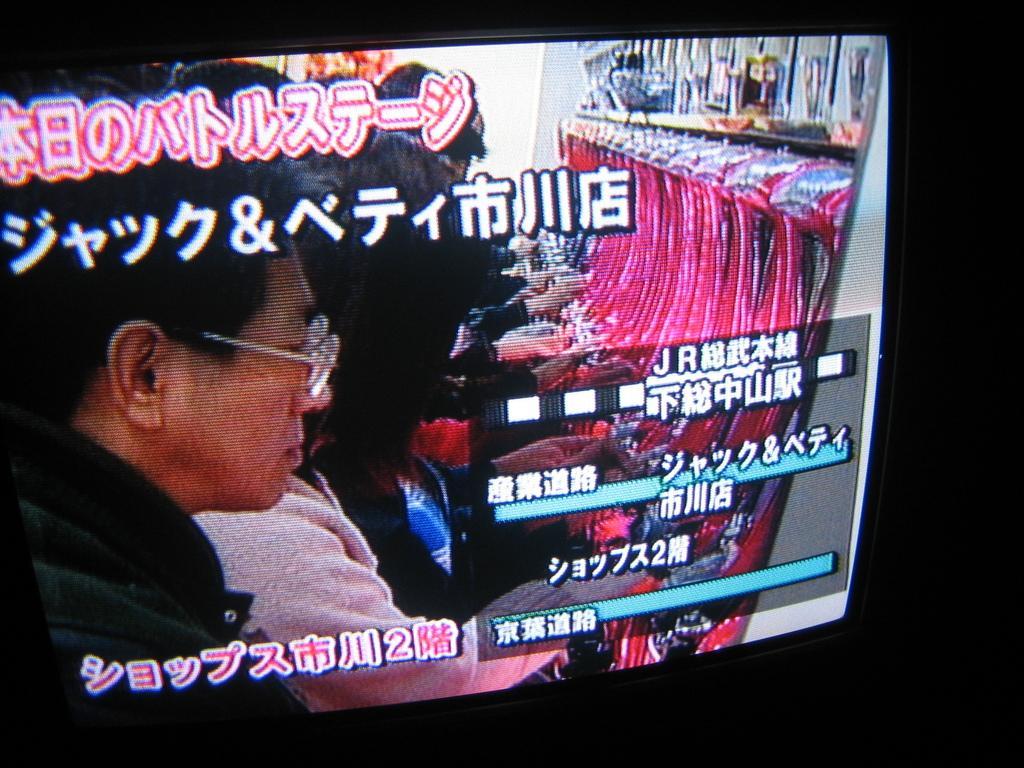Can you describe this image briefly? On this screen we can see people and things. Something written on this screen. 